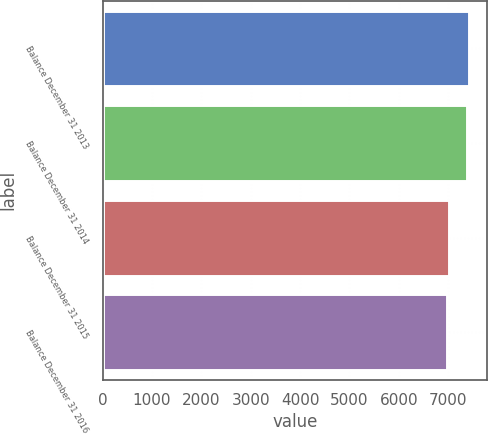<chart> <loc_0><loc_0><loc_500><loc_500><bar_chart><fcel>Balance December 31 2013<fcel>Balance December 31 2014<fcel>Balance December 31 2015<fcel>Balance December 31 2016<nl><fcel>7425.95<fcel>7382.1<fcel>7014.75<fcel>6970.9<nl></chart> 